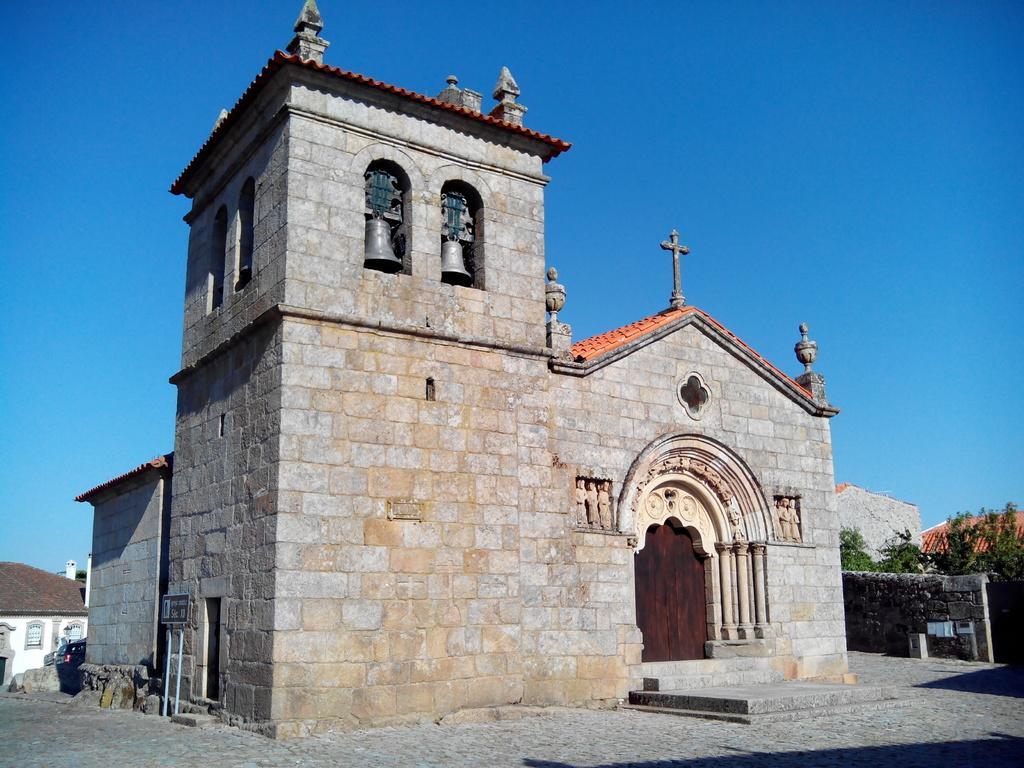Could you give a brief overview of what you see in this image? In the foreground of this image, there is a building and a pavement. In the background, there are few houses, trees, wall and the sky. 